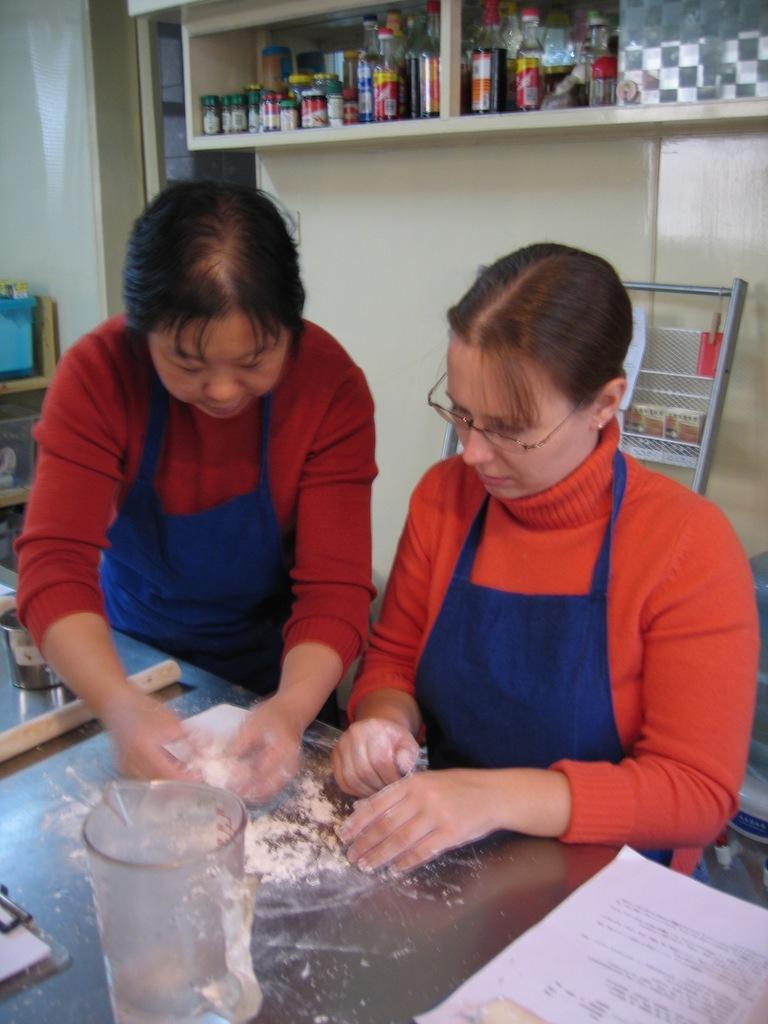Describe this image in one or two sentences. This picture is clicked inside the room. In the foreground there is a table on the top of which a jug, paper and some other items are placed and we can see a person and a person holding some object and standing. In the background we can see the wall, cabinets containing bottles and some other objects and we can see there are some objects in the background. 